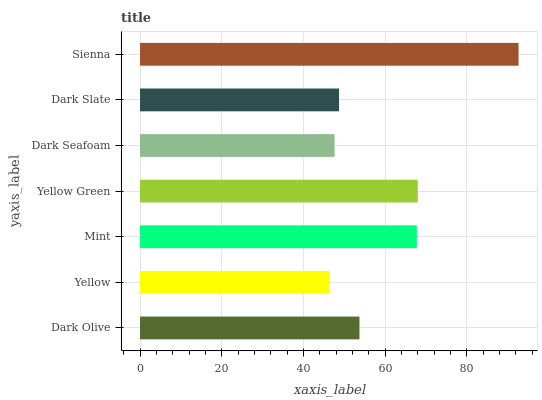Is Yellow the minimum?
Answer yes or no. Yes. Is Sienna the maximum?
Answer yes or no. Yes. Is Mint the minimum?
Answer yes or no. No. Is Mint the maximum?
Answer yes or no. No. Is Mint greater than Yellow?
Answer yes or no. Yes. Is Yellow less than Mint?
Answer yes or no. Yes. Is Yellow greater than Mint?
Answer yes or no. No. Is Mint less than Yellow?
Answer yes or no. No. Is Dark Olive the high median?
Answer yes or no. Yes. Is Dark Olive the low median?
Answer yes or no. Yes. Is Yellow the high median?
Answer yes or no. No. Is Sienna the low median?
Answer yes or no. No. 